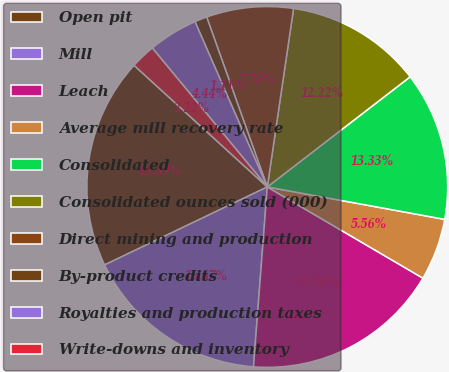Convert chart to OTSL. <chart><loc_0><loc_0><loc_500><loc_500><pie_chart><fcel>Open pit<fcel>Mill<fcel>Leach<fcel>Average mill recovery rate<fcel>Consolidated<fcel>Consolidated ounces sold (000)<fcel>Direct mining and production<fcel>By-product credits<fcel>Royalties and production taxes<fcel>Write-downs and inventory<nl><fcel>18.89%<fcel>16.67%<fcel>17.78%<fcel>5.56%<fcel>13.33%<fcel>12.22%<fcel>7.78%<fcel>1.11%<fcel>4.44%<fcel>2.22%<nl></chart> 